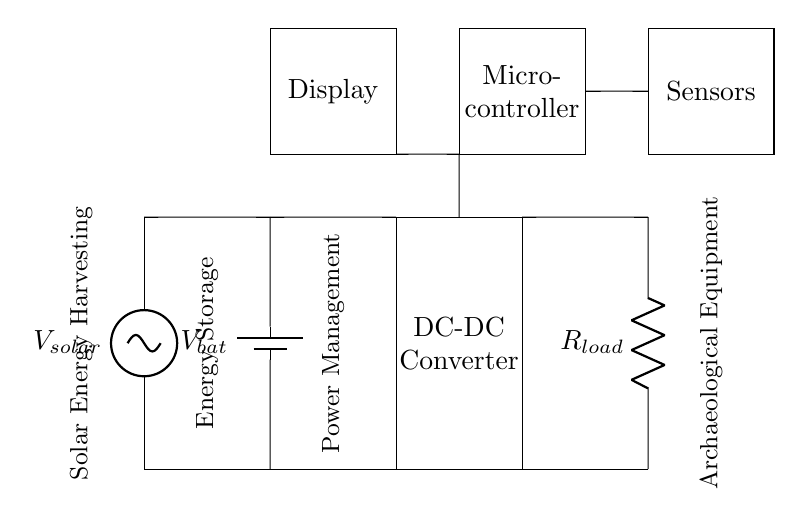What is the voltage source in this circuit? The voltage source in the circuit is the solar panel, indicated as \(V_{solar}\). It provides the initial voltage required for the system to operate.
Answer: solar panel What components are used for energy storage in this circuit? The component used for energy storage is the battery, as labeled with \(V_{bat}\) in the circuit diagram. Batteries store energy for later use when the solar energy is not sufficient.
Answer: battery Which component regulates the voltage in the circuit? The component that regulates the voltage is the DC-DC converter, as it is designed to maintain a stable output voltage regardless of variations in input voltage.
Answer: DC-DC converter How do sensors fit into the power management system? The sensors receive power from the power management system to function and monitor the archaeological equipment's status, making them an integral part of data collection.
Answer: power supply for sensors What role does the microcontroller play in this circuit? The microcontroller is responsible for processing the data from the sensors and controlling the overall operation of the system, including managing power distribution.
Answer: control system What is the purpose of the resistance connected as \(R_{load}\)? The resistor, labeled as \(R_{load}\), simulates the load that the system needs to supply power to, representing the energy consumed by the archaeological equipment.
Answer: load simulation What is the main function of the display in this setup? The display is used to present information, such as sensor readings or system status, allowing users to interface with and monitor the system effectively.
Answer: information display 